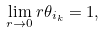Convert formula to latex. <formula><loc_0><loc_0><loc_500><loc_500>\lim _ { r \rightarrow 0 } r \theta _ { i _ { k } } = 1 ,</formula> 